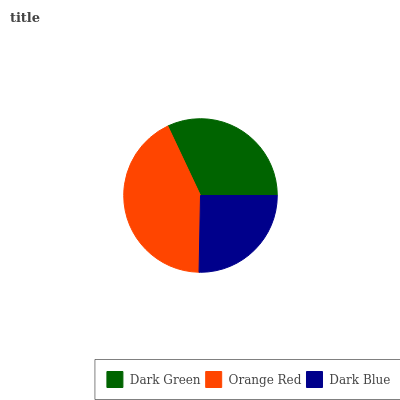Is Dark Blue the minimum?
Answer yes or no. Yes. Is Orange Red the maximum?
Answer yes or no. Yes. Is Orange Red the minimum?
Answer yes or no. No. Is Dark Blue the maximum?
Answer yes or no. No. Is Orange Red greater than Dark Blue?
Answer yes or no. Yes. Is Dark Blue less than Orange Red?
Answer yes or no. Yes. Is Dark Blue greater than Orange Red?
Answer yes or no. No. Is Orange Red less than Dark Blue?
Answer yes or no. No. Is Dark Green the high median?
Answer yes or no. Yes. Is Dark Green the low median?
Answer yes or no. Yes. Is Orange Red the high median?
Answer yes or no. No. Is Dark Blue the low median?
Answer yes or no. No. 